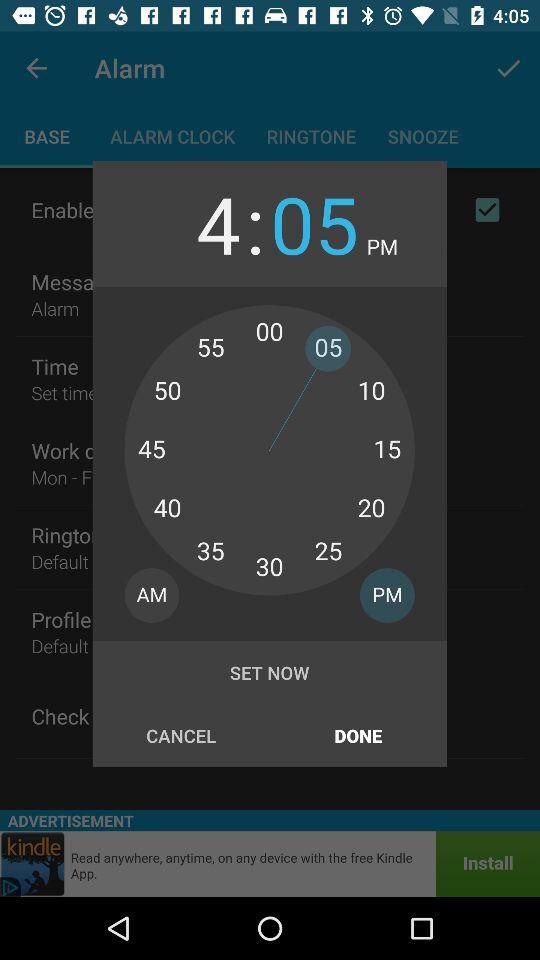What time is selected for the alarm? The selected time is 4:05 PM. 